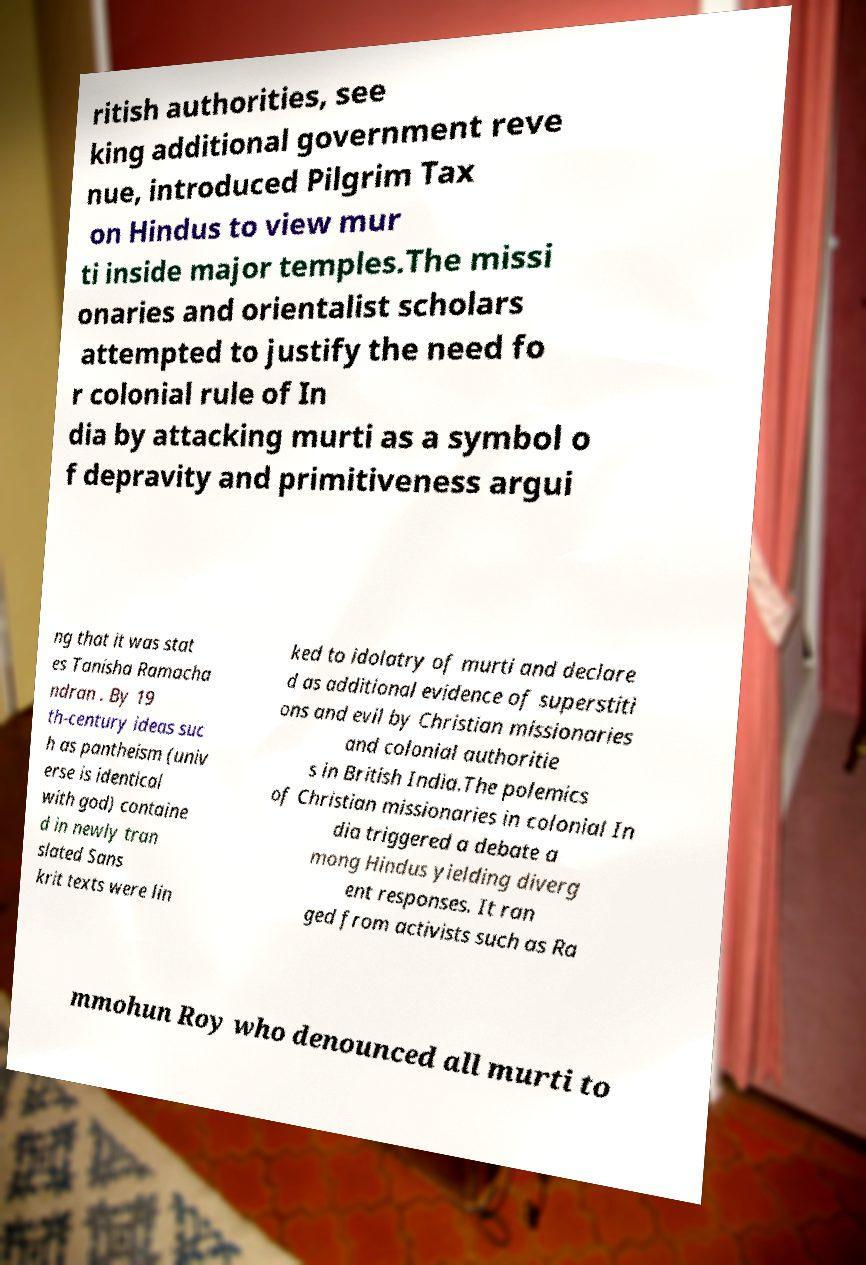For documentation purposes, I need the text within this image transcribed. Could you provide that? ritish authorities, see king additional government reve nue, introduced Pilgrim Tax on Hindus to view mur ti inside major temples.The missi onaries and orientalist scholars attempted to justify the need fo r colonial rule of In dia by attacking murti as a symbol o f depravity and primitiveness argui ng that it was stat es Tanisha Ramacha ndran . By 19 th-century ideas suc h as pantheism (univ erse is identical with god) containe d in newly tran slated Sans krit texts were lin ked to idolatry of murti and declare d as additional evidence of superstiti ons and evil by Christian missionaries and colonial authoritie s in British India.The polemics of Christian missionaries in colonial In dia triggered a debate a mong Hindus yielding diverg ent responses. It ran ged from activists such as Ra mmohun Roy who denounced all murti to 